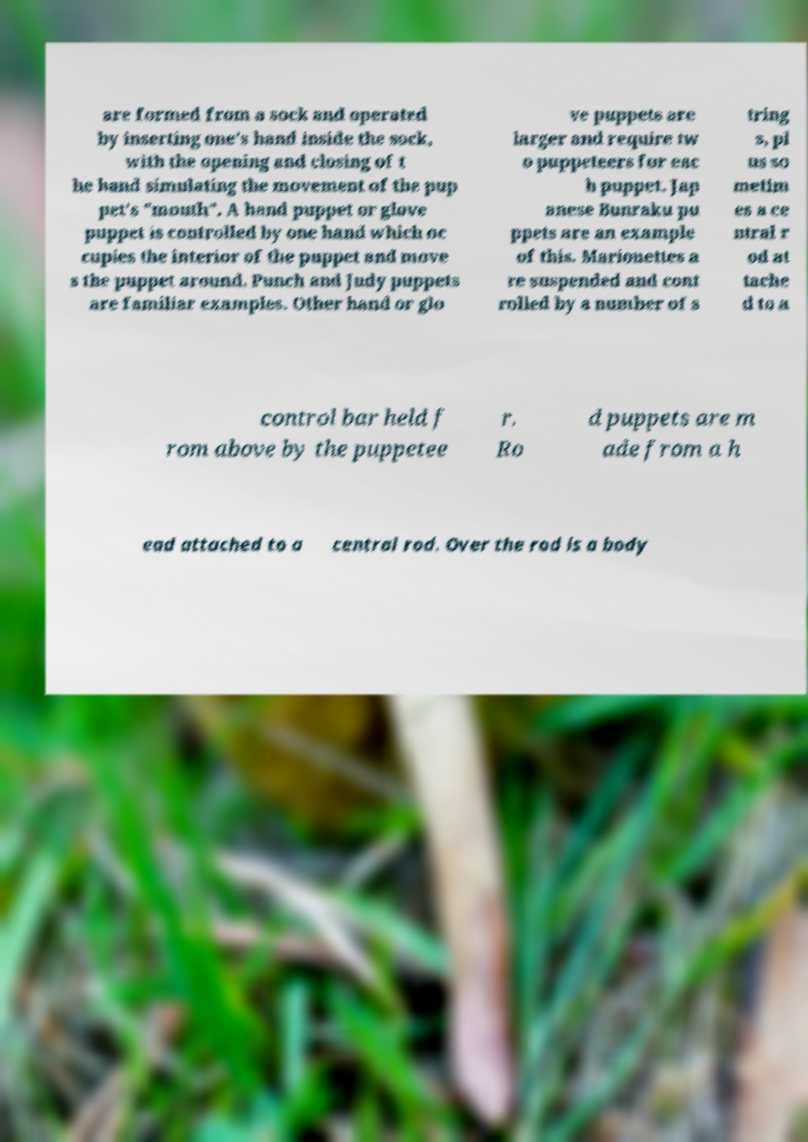I need the written content from this picture converted into text. Can you do that? are formed from a sock and operated by inserting one's hand inside the sock, with the opening and closing of t he hand simulating the movement of the pup pet's "mouth". A hand puppet or glove puppet is controlled by one hand which oc cupies the interior of the puppet and move s the puppet around. Punch and Judy puppets are familiar examples. Other hand or glo ve puppets are larger and require tw o puppeteers for eac h puppet. Jap anese Bunraku pu ppets are an example of this. Marionettes a re suspended and cont rolled by a number of s tring s, pl us so metim es a ce ntral r od at tache d to a control bar held f rom above by the puppetee r. Ro d puppets are m ade from a h ead attached to a central rod. Over the rod is a body 